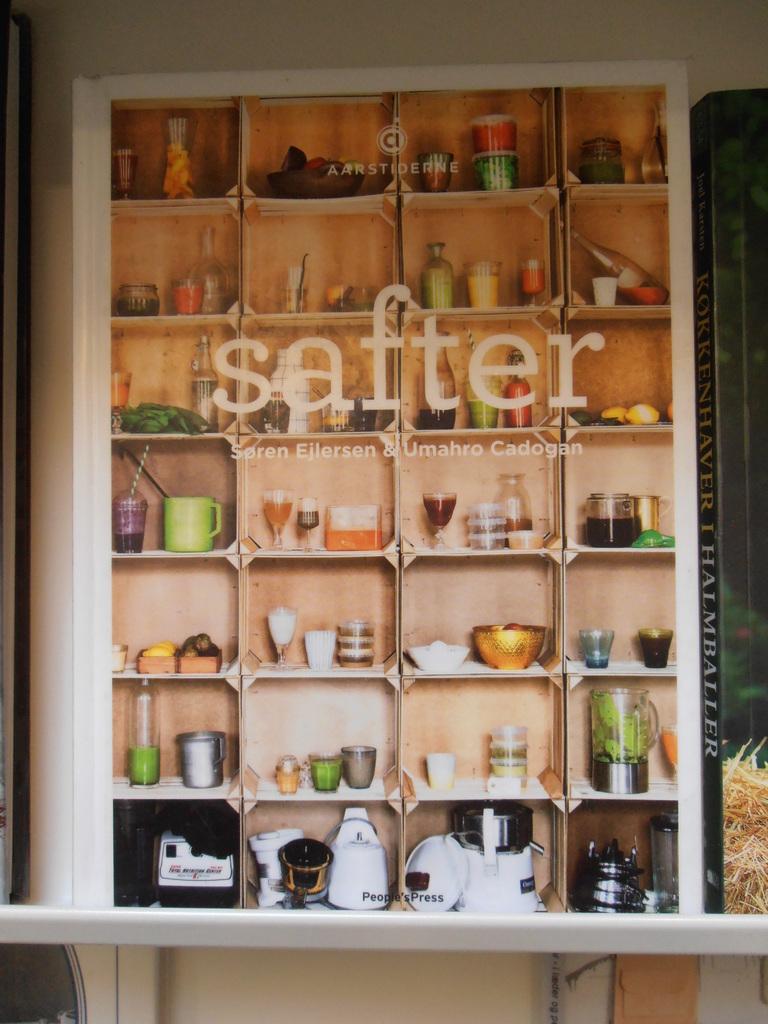What is the big word on the shelves?
Ensure brevity in your answer.  Safter. 